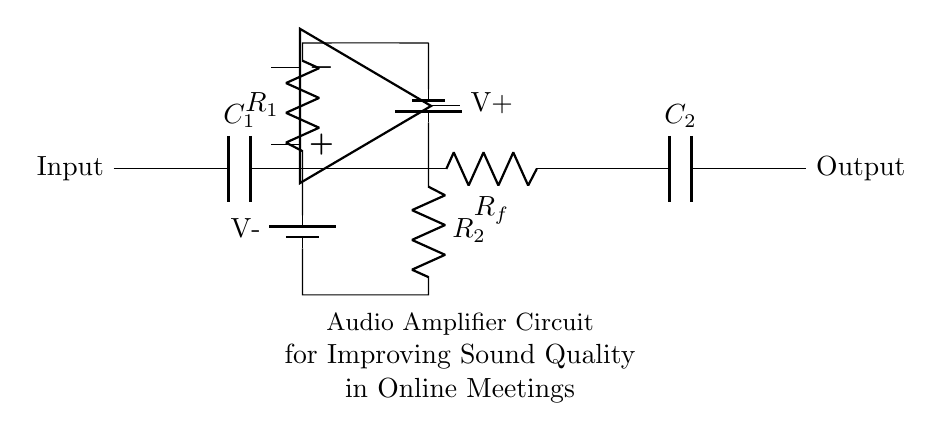What is the input component in this circuit? The input component is a capacitor labeled C1 that connects the input signal to the amplifier stage.
Answer: C1 What is the role of the op-amp in this circuit? The operational amplifier (op-amp) amplifies the input signal received via resistors and capacitors, thus improving the sound quality for online meetings.
Answer: Amplification How many resistors are present in the circuit? There are three resistors in the circuit, labeled R1, R2, and Rf, each serving distinct functions in the amplification process.
Answer: 3 What is the significance of Rf in the circuit? Resistor Rf provides feedback from the output to the inverting input of the op-amp, controlling the gain of the amplifier.
Answer: Feedback What is the output component of this circuit? The output component is a capacitor labeled C2, which helps smooth the amplified signal before it is sent out.
Answer: C2 What does the presence of two capacitors indicate about this amplifier circuit? The two capacitors, C1 and C2, are used for coupling and decoupling, allowing AC signals to pass while blocking DC components, thereby maintaining signal integrity.
Answer: Coupling and decoupling What is the voltage supply configuration in this circuit? The circuit uses a dual voltage supply, with V+ for the positive side and V- for the negative side, ensuring the op-amp operates correctly with bipolar voltages.
Answer: Dual supply 